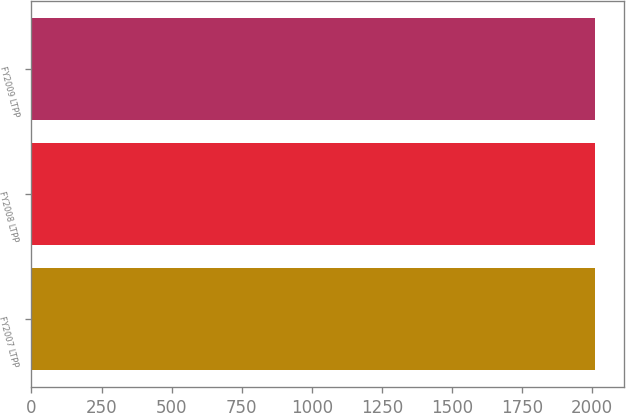Convert chart. <chart><loc_0><loc_0><loc_500><loc_500><bar_chart><fcel>FY2007 LTPP<fcel>FY2008 LTPP<fcel>FY2009 LTPP<nl><fcel>2010<fcel>2011<fcel>2012<nl></chart> 